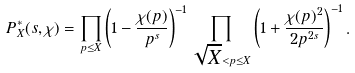Convert formula to latex. <formula><loc_0><loc_0><loc_500><loc_500>P _ { X } ^ { * } ( s , \chi ) = \prod _ { p \leq X } \left ( 1 - \frac { \chi ( p ) } { p ^ { s } } \right ) ^ { - 1 } \prod _ { \sqrt { X } < p \leq X } \left ( 1 + \frac { \chi ( p ) ^ { 2 } } { 2 p ^ { 2 s } } \right ) ^ { - 1 } .</formula> 